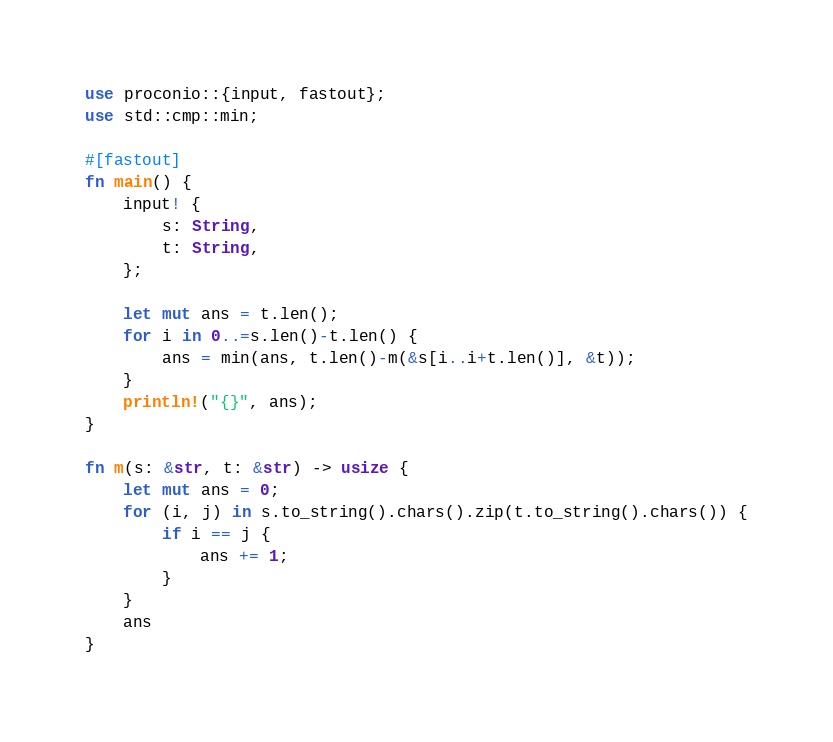<code> <loc_0><loc_0><loc_500><loc_500><_Rust_>use proconio::{input, fastout};
use std::cmp::min;

#[fastout]
fn main() {
    input! {
        s: String,
        t: String,
    };

    let mut ans = t.len();
    for i in 0..=s.len()-t.len() {
        ans = min(ans, t.len()-m(&s[i..i+t.len()], &t));
    }
    println!("{}", ans);
}

fn m(s: &str, t: &str) -> usize {
    let mut ans = 0;
    for (i, j) in s.to_string().chars().zip(t.to_string().chars()) {
        if i == j {
            ans += 1;
        }
    }
    ans
}
</code> 